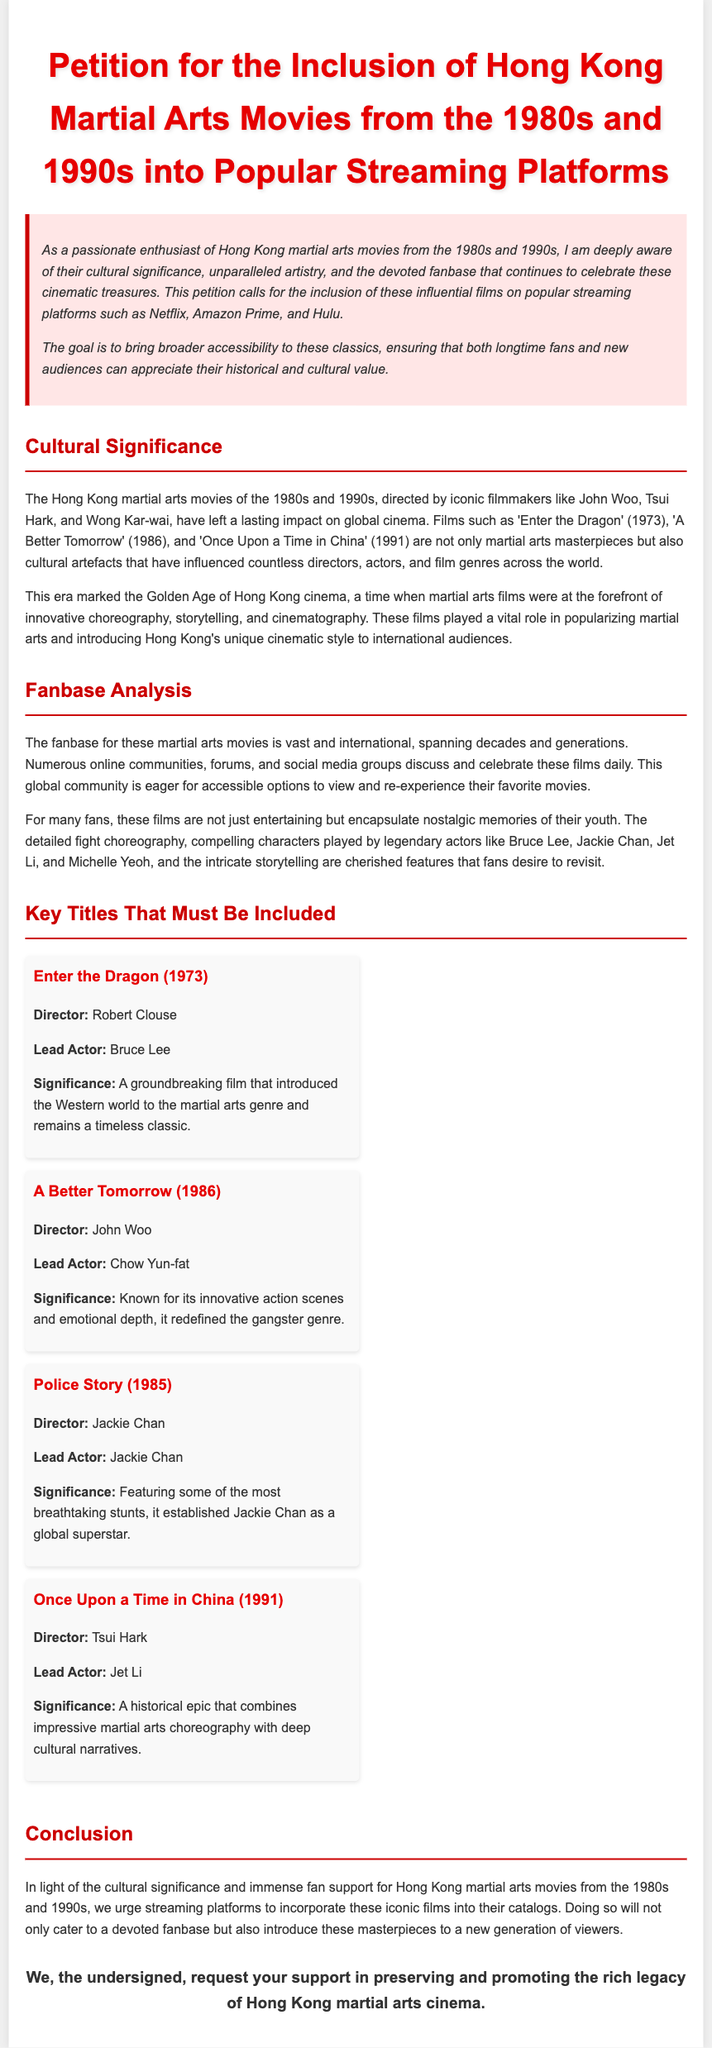What is the title of the petition? The title is clearly stated at the top of the document, indicating the subject matter.
Answer: Petition for the Inclusion of Hong Kong Martial Arts Movies from the 1980s and 1990s into Popular Streaming Platforms Who directed "Enter the Dragon"? The document lists directors alongside key titles, making this information easily retrievable.
Answer: Robert Clouse Which actor starred in "A Better Tomorrow"? The document specifies lead actors for each film, directly associating them with their respective titles.
Answer: Chow Yun-fat What year was "Once Upon a Time in China" released? The release year is mentioned within the context of the film's description, allowing for quick reference.
Answer: 1991 What genre did the Hong Kong martial arts films influence? The document discusses the broader impact of these films on popular cinema, including specific genres.
Answer: Martial arts genre Why are these films significant to fans? The document explains factors contributing to the films' importance to the community and their emotional connection to viewers.
Answer: Nostalgic memories What film is noted for establishing Jackie Chan as a global superstar? Specific films are highlighted for their contributions to actors' careers within the petition's context.
Answer: Police Story How did the director Tsui Hark contribute to the era? The document mentions significant directors, linking them to their celebrated works during this notable period in cinema.
Answer: Once Upon a Time in China What is the ultimate goal of the petition? The introductory section outlines the primary aim of the petition in advocating for these films on streaming platforms.
Answer: Broader accessibility 